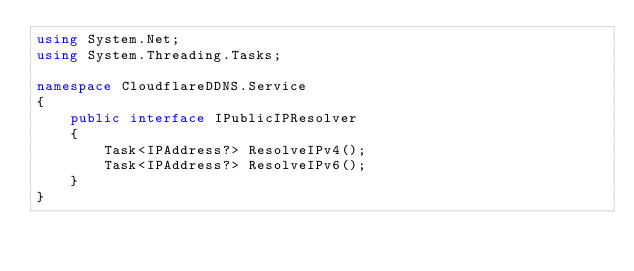<code> <loc_0><loc_0><loc_500><loc_500><_C#_>using System.Net;
using System.Threading.Tasks;

namespace CloudflareDDNS.Service
{
    public interface IPublicIPResolver
    {
        Task<IPAddress?> ResolveIPv4();
        Task<IPAddress?> ResolveIPv6();
    }
}
</code> 